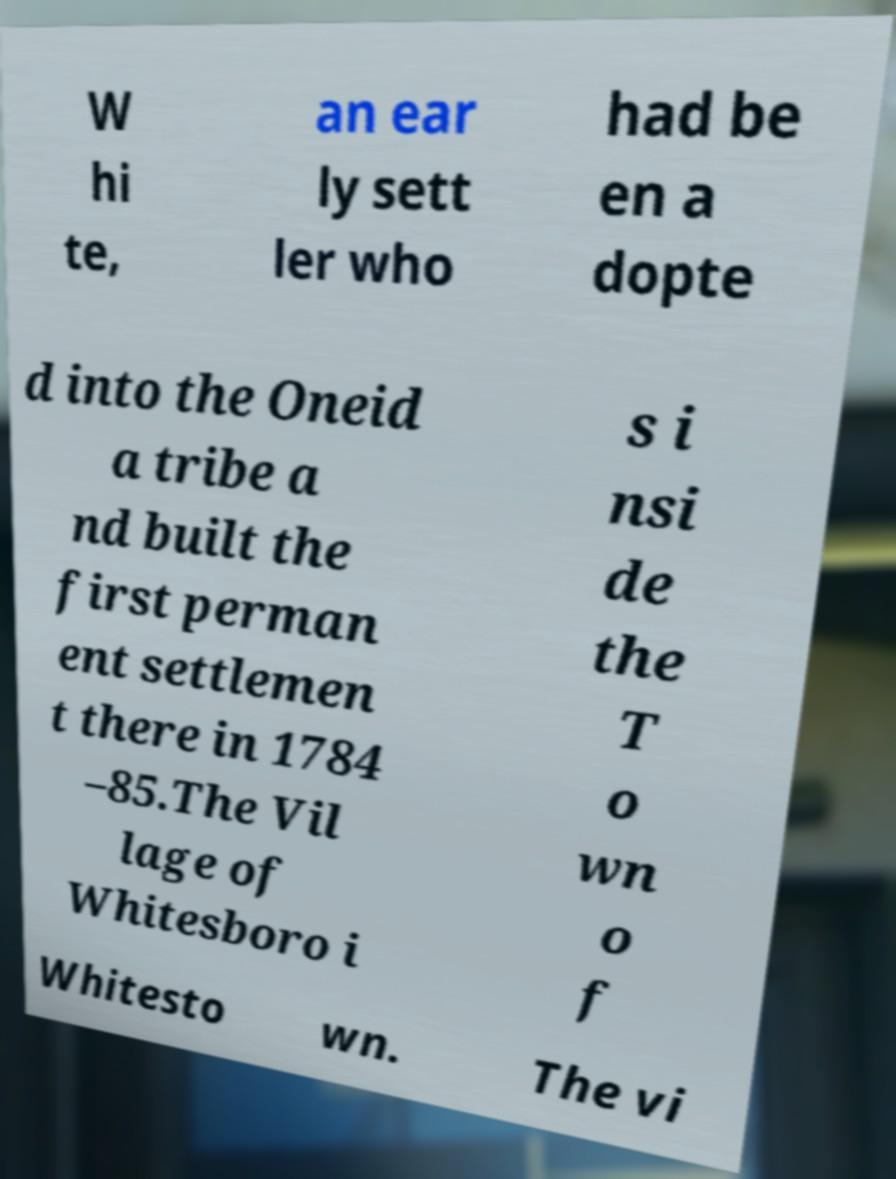Please read and relay the text visible in this image. What does it say? W hi te, an ear ly sett ler who had be en a dopte d into the Oneid a tribe a nd built the first perman ent settlemen t there in 1784 –85.The Vil lage of Whitesboro i s i nsi de the T o wn o f Whitesto wn. The vi 